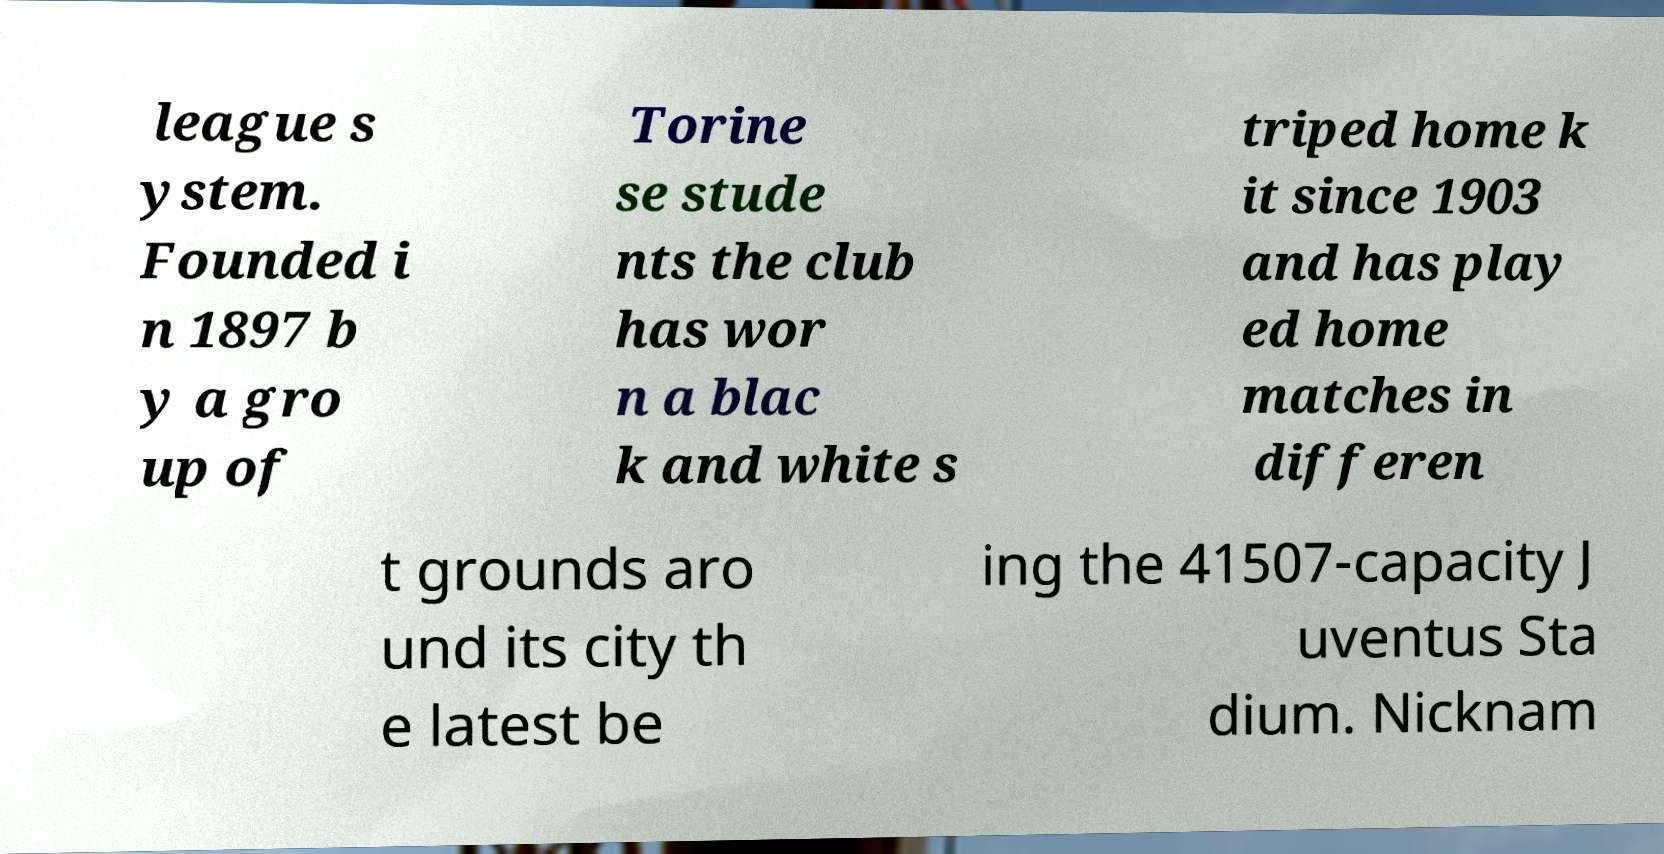Could you assist in decoding the text presented in this image and type it out clearly? league s ystem. Founded i n 1897 b y a gro up of Torine se stude nts the club has wor n a blac k and white s triped home k it since 1903 and has play ed home matches in differen t grounds aro und its city th e latest be ing the 41507-capacity J uventus Sta dium. Nicknam 